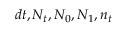Convert formula to latex. <formula><loc_0><loc_0><loc_500><loc_500>d t , N _ { t } , N _ { 0 } , N _ { 1 } , n _ { t }</formula> 